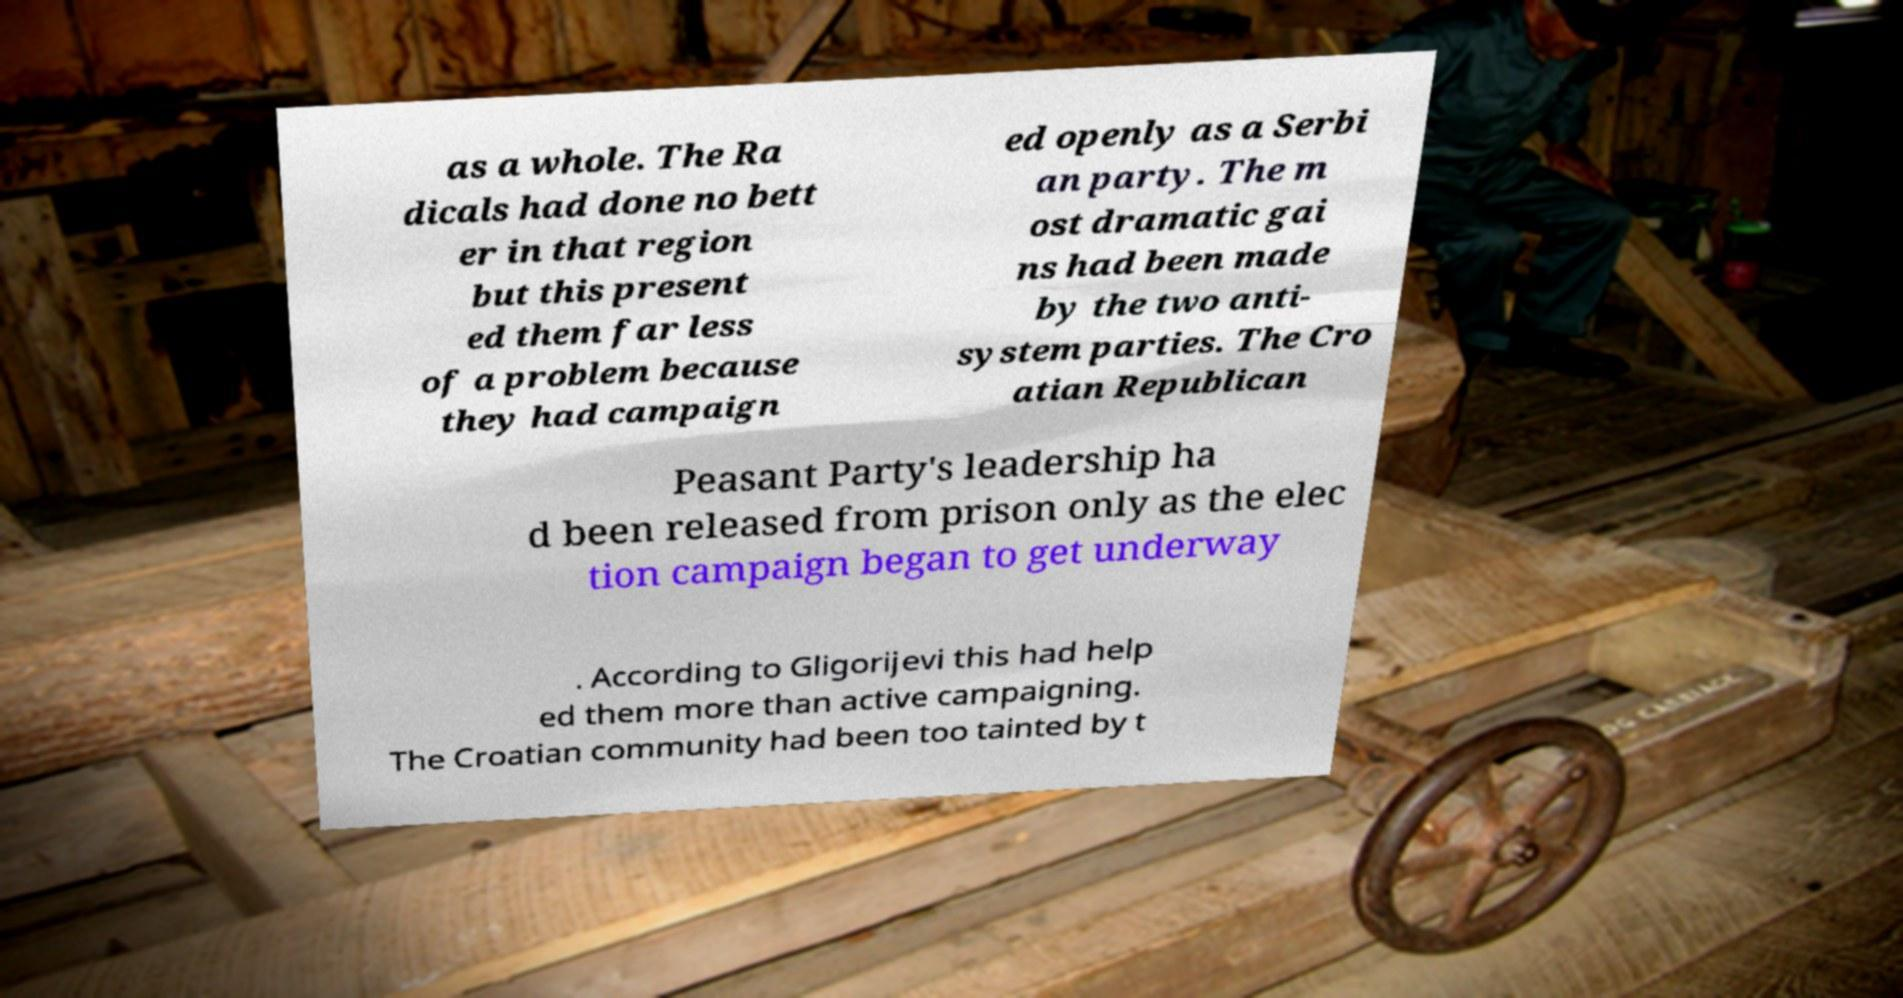Could you assist in decoding the text presented in this image and type it out clearly? as a whole. The Ra dicals had done no bett er in that region but this present ed them far less of a problem because they had campaign ed openly as a Serbi an party. The m ost dramatic gai ns had been made by the two anti- system parties. The Cro atian Republican Peasant Party's leadership ha d been released from prison only as the elec tion campaign began to get underway . According to Gligorijevi this had help ed them more than active campaigning. The Croatian community had been too tainted by t 